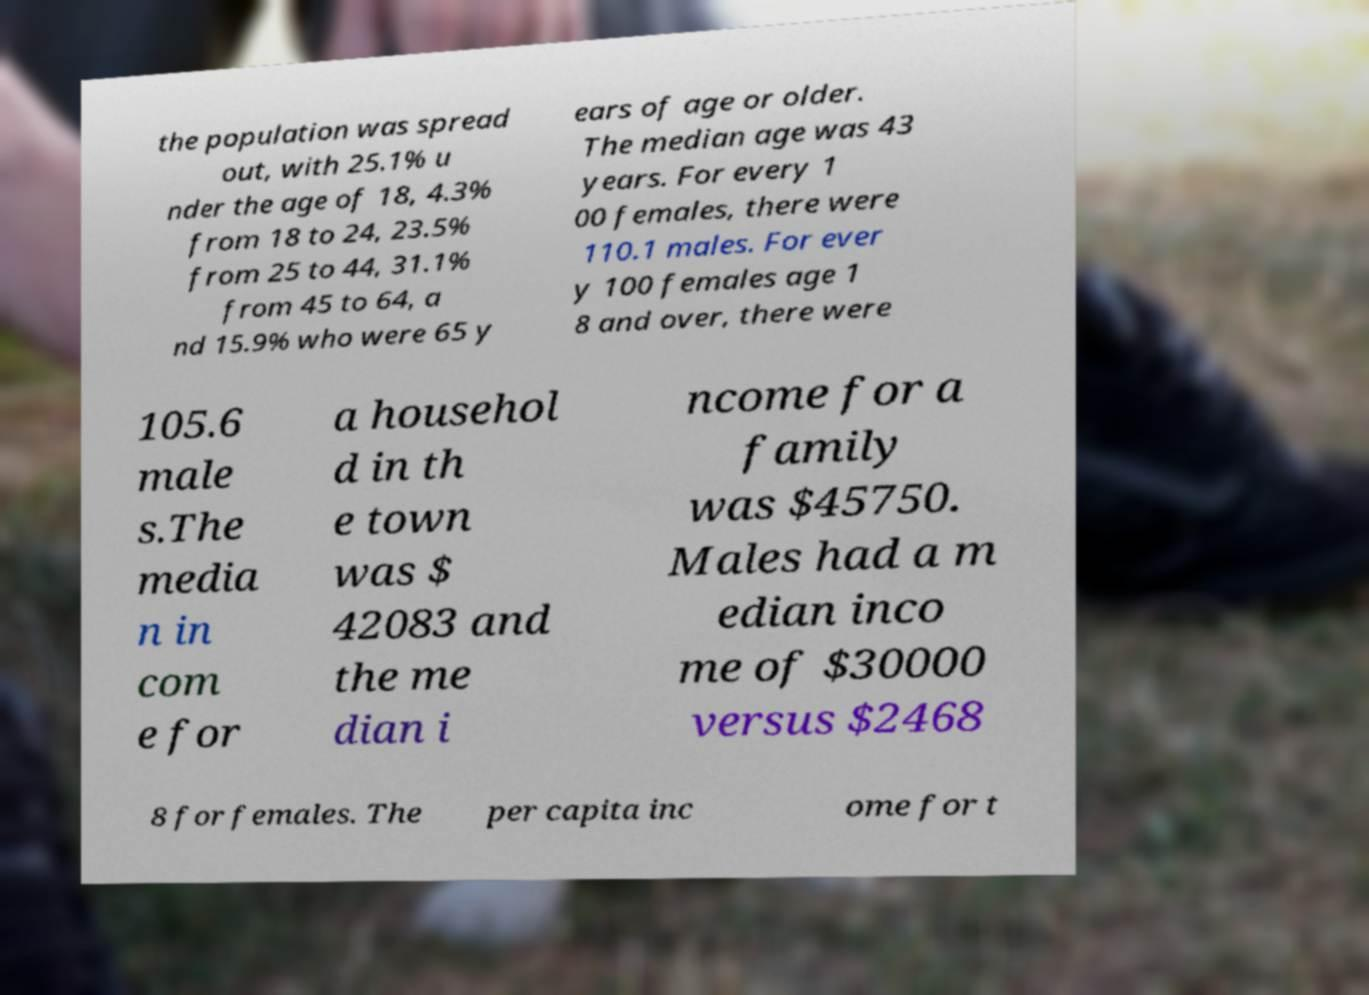Please read and relay the text visible in this image. What does it say? the population was spread out, with 25.1% u nder the age of 18, 4.3% from 18 to 24, 23.5% from 25 to 44, 31.1% from 45 to 64, a nd 15.9% who were 65 y ears of age or older. The median age was 43 years. For every 1 00 females, there were 110.1 males. For ever y 100 females age 1 8 and over, there were 105.6 male s.The media n in com e for a househol d in th e town was $ 42083 and the me dian i ncome for a family was $45750. Males had a m edian inco me of $30000 versus $2468 8 for females. The per capita inc ome for t 